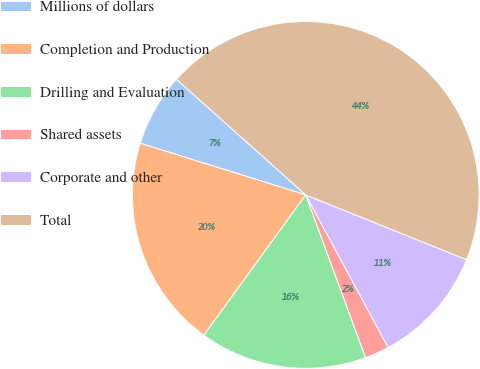Convert chart to OTSL. <chart><loc_0><loc_0><loc_500><loc_500><pie_chart><fcel>Millions of dollars<fcel>Completion and Production<fcel>Drilling and Evaluation<fcel>Shared assets<fcel>Corporate and other<fcel>Total<nl><fcel>6.8%<fcel>19.82%<fcel>15.6%<fcel>2.28%<fcel>11.02%<fcel>44.49%<nl></chart> 